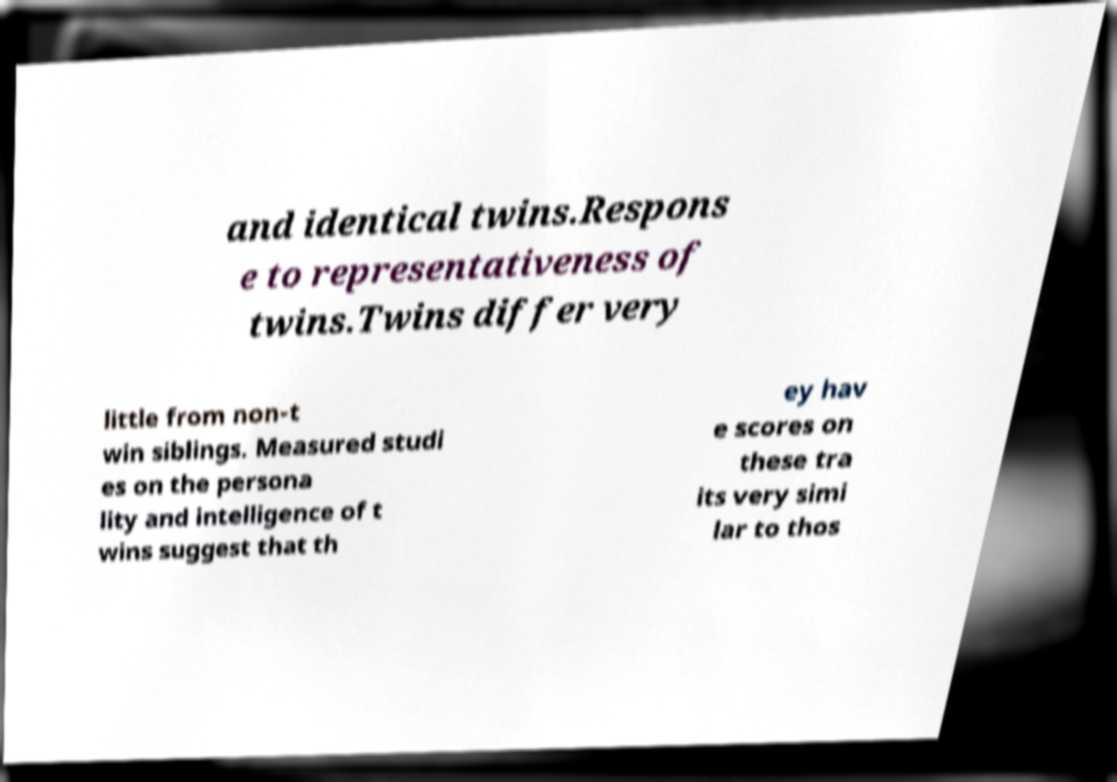Can you accurately transcribe the text from the provided image for me? and identical twins.Respons e to representativeness of twins.Twins differ very little from non-t win siblings. Measured studi es on the persona lity and intelligence of t wins suggest that th ey hav e scores on these tra its very simi lar to thos 